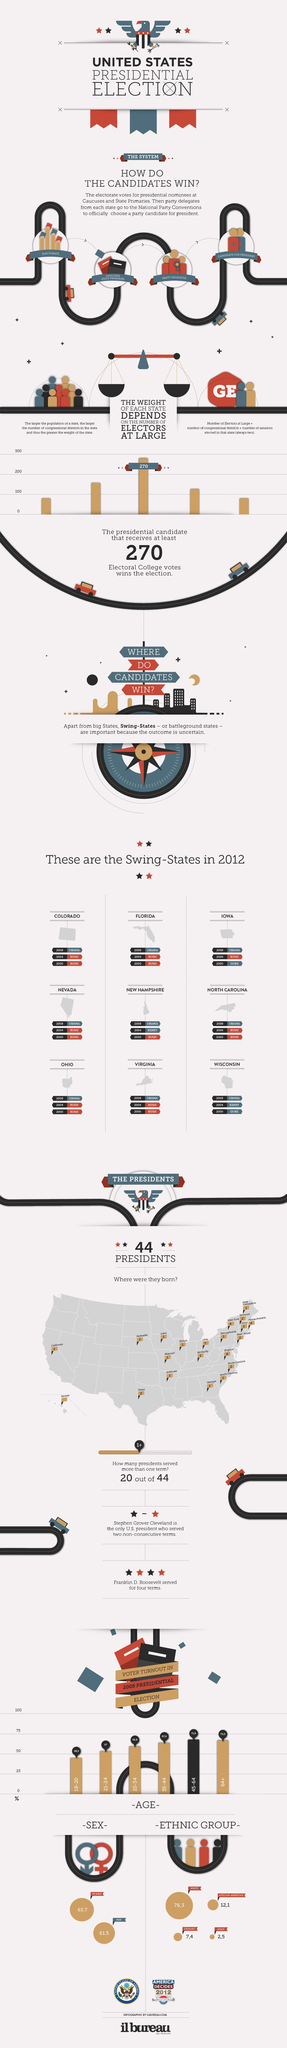Outline some significant characteristics in this image. The total voter turnout for individuals below the age of 21 was 48.5%. The candidate for president is chosen at national party conventions. Virginia was the birth state for the most number of presidents. African-Americans had the second highest voter turnout in the most recent election. In the 2012 presidential election, there were a total of 9 swing states. 